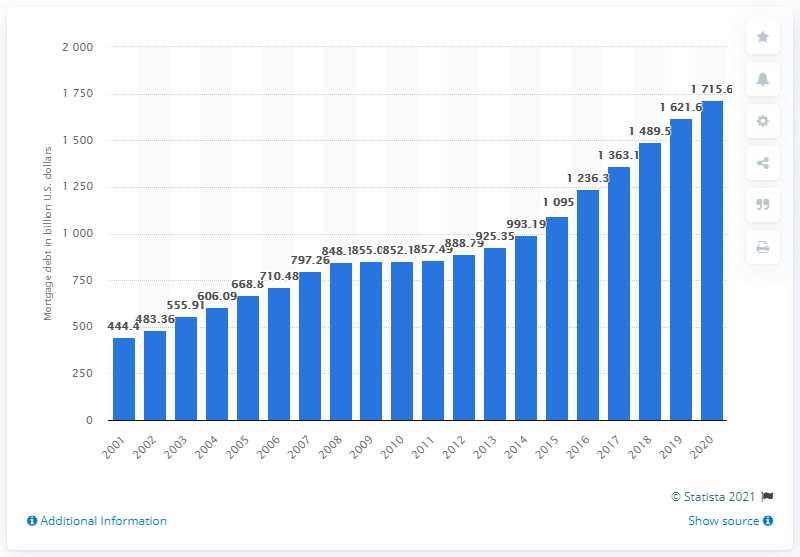Highlight a few significant elements in this photo. In 2020, the total amount of mortgage debt outstanding on multifamily residences in the United States was $171,560,000. 